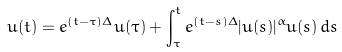<formula> <loc_0><loc_0><loc_500><loc_500>u ( t ) = e ^ { ( t - \tau ) \Delta } u ( \tau ) + \int _ { \tau } ^ { t } e ^ { ( t - s ) \Delta } | u ( s ) | ^ { \alpha } u ( s ) \, d s</formula> 